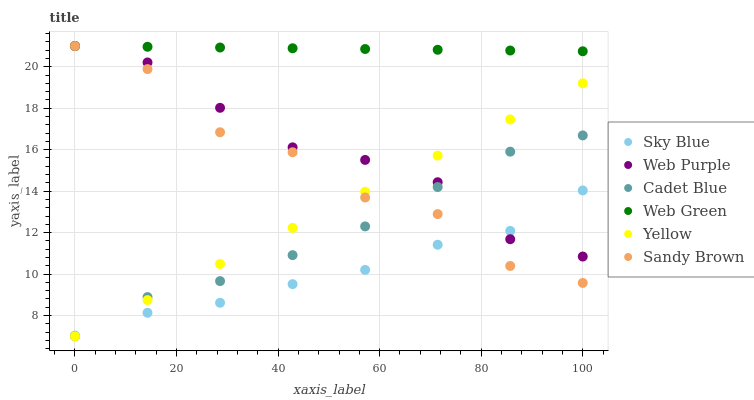Does Sky Blue have the minimum area under the curve?
Answer yes or no. Yes. Does Web Green have the maximum area under the curve?
Answer yes or no. Yes. Does Yellow have the minimum area under the curve?
Answer yes or no. No. Does Yellow have the maximum area under the curve?
Answer yes or no. No. Is Yellow the smoothest?
Answer yes or no. Yes. Is Sandy Brown the roughest?
Answer yes or no. Yes. Is Web Purple the smoothest?
Answer yes or no. No. Is Web Purple the roughest?
Answer yes or no. No. Does Cadet Blue have the lowest value?
Answer yes or no. Yes. Does Web Purple have the lowest value?
Answer yes or no. No. Does Sandy Brown have the highest value?
Answer yes or no. Yes. Does Yellow have the highest value?
Answer yes or no. No. Is Cadet Blue less than Web Green?
Answer yes or no. Yes. Is Web Green greater than Cadet Blue?
Answer yes or no. Yes. Does Cadet Blue intersect Sandy Brown?
Answer yes or no. Yes. Is Cadet Blue less than Sandy Brown?
Answer yes or no. No. Is Cadet Blue greater than Sandy Brown?
Answer yes or no. No. Does Cadet Blue intersect Web Green?
Answer yes or no. No. 